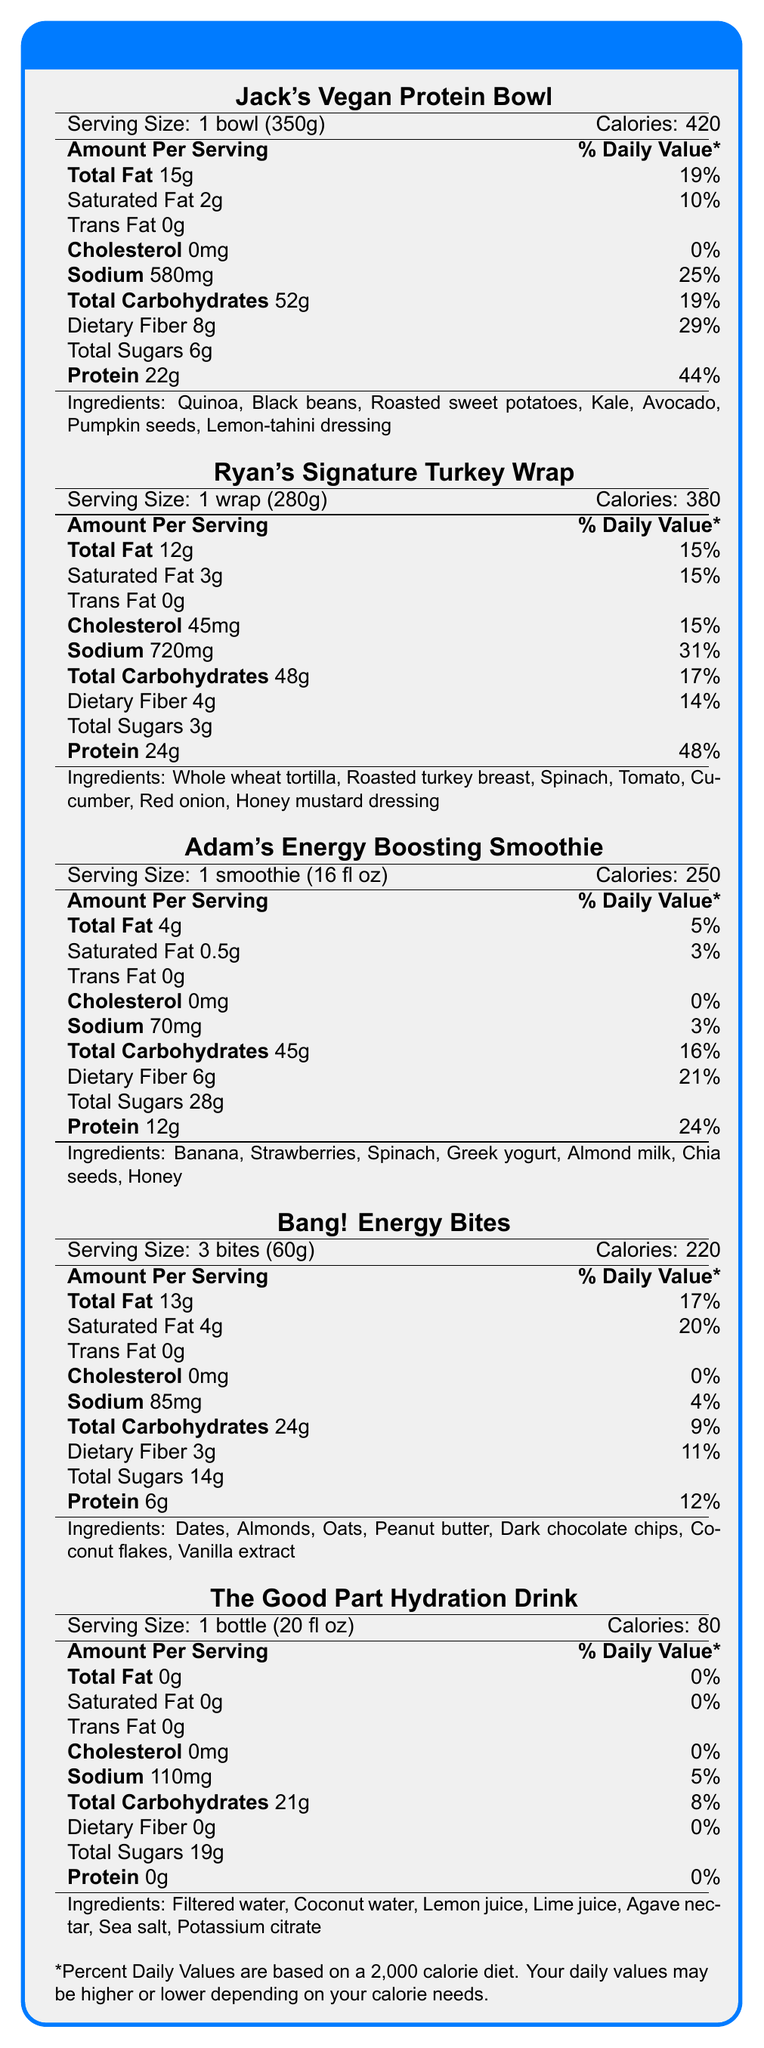what is the serving size of Jack's Vegan Protein Bowl? The serving size is explicitly listed as "1 bowl (350g)" under the section for Jack's Vegan Protein Bowl.
Answer: 1 bowl (350g) how many grams of protein does Ryan's Signature Turkey Wrap contain? The protein content for Ryan's Signature Turkey Wrap is listed as 24 grams in the document.
Answer: 24 grams which menu item has the lowest calorie content per serving? The Good Part Hydration Drink contains 80 calories per serving, which is the lowest among the listed items.
Answer: The Good Part Hydration Drink List three ingredients in Adam's Energy Boosting Smoothie. The ingredients section for Adam's Energy Boosting Smoothie lists Banana, Strawberries, Spinach, among other ingredients.
Answer: Banana, Strawberries, Spinach what is the percentage of Daily Value for total carbohydrates in the Bang! Energy Bites? The percentage of Daily Value for total carbohydrates in the Bang! Energy Bites is listed as 9%.
Answer: 9% Which item has the highest amount of total sugars? A. Jack's Vegan Protein Bowl B. Ryan's Signature Turkey Wrap C. Adam's Energy Boosting Smoothie D. The Good Part Hydration Drink Adam's Energy Boosting Smoothie contains 28 grams of total sugars, which is the highest among the listed options.
Answer: C. Adam's Energy Boosting Smoothie Which of the following items contains dietary fiber? I. Ryan's Signature Turkey Wrap II. Adam's Energy Boosting Smoothie III. Bang! Energy Bites IV. The Good Part Hydration Drink Ryan's Signature Turkey Wrap (4g), Adam's Energy Boosting Smoothie (6g), and Bang! Energy Bites (3g) contain dietary fiber. The Good Part Hydration Drink does not contain dietary fiber.
Answer: I, II, III Does Jack's Vegan Protein Bowl contain any cholesterol? The Nutrition Facts Label for Jack's Vegan Protein Bowl shows 0mg of cholesterol, indicating it contains no cholesterol.
Answer: No Summarize the nutritional information provided in the AJR Tour Catering Menu document. The document comprehensively lists the nutritional facts of various menu items, allowing readers to understand the nutritional content and ingredients of each item. This information can help make informed dietary choices.
Answer: The AJR Tour Catering Menu provides nutritional information for five menu items, including serving size, calorie content, and breakdown of macronutrients and other nutrients. Each item includes a list of ingredients and the percentage of Daily Values based on a 2,000 calorie diet. The items cater to different dietary preferences and include a vegan protein bowl, turkey wrap, energy-boosting smoothie, energy bites, and a hydration drink. What is the name of the chef who created the menu? The document does not provide any information about the chef who created the menu.
Answer: Not enough information which item has the highest sodium content? Ryan's Signature Turkey Wrap contains 720mg of sodium, which is the highest among the listed items.
Answer: Ryan's Signature Turkey Wrap 